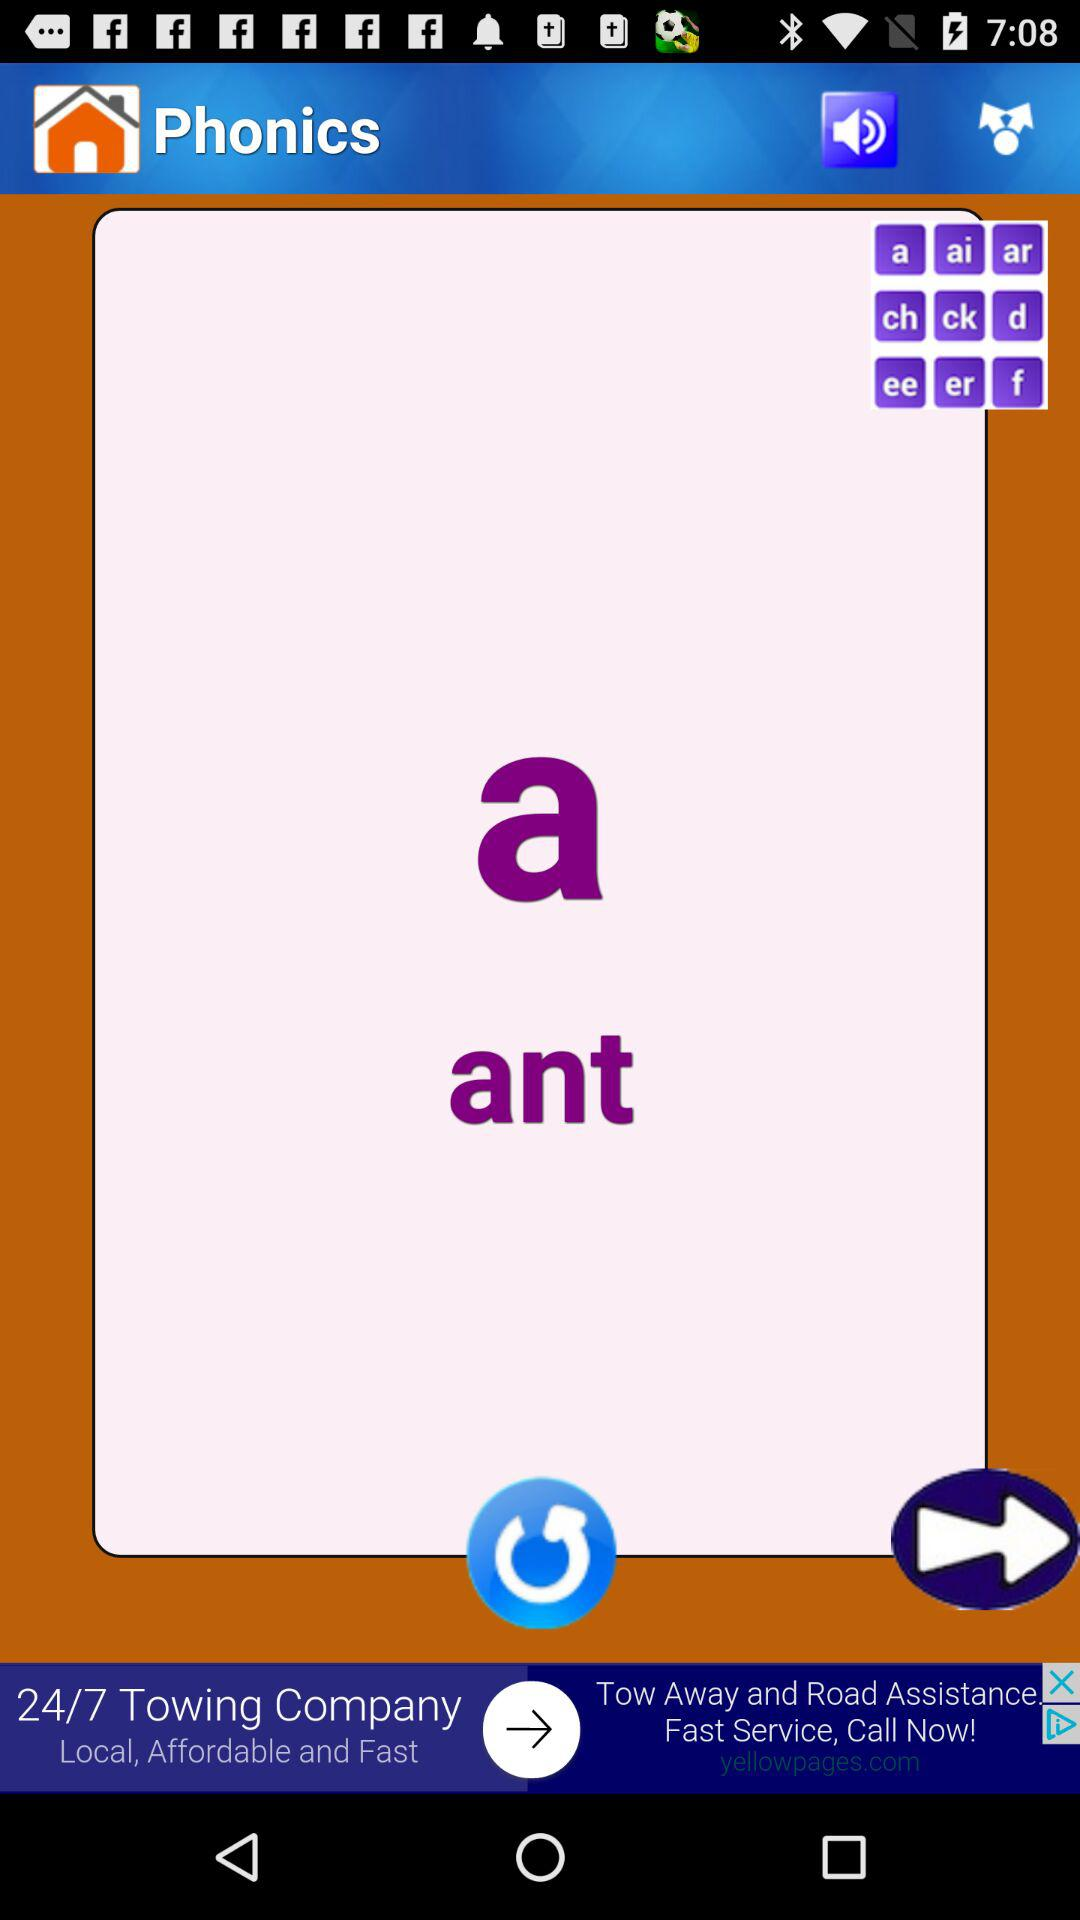What is the name of the application? The name of the application is "Phonics". 